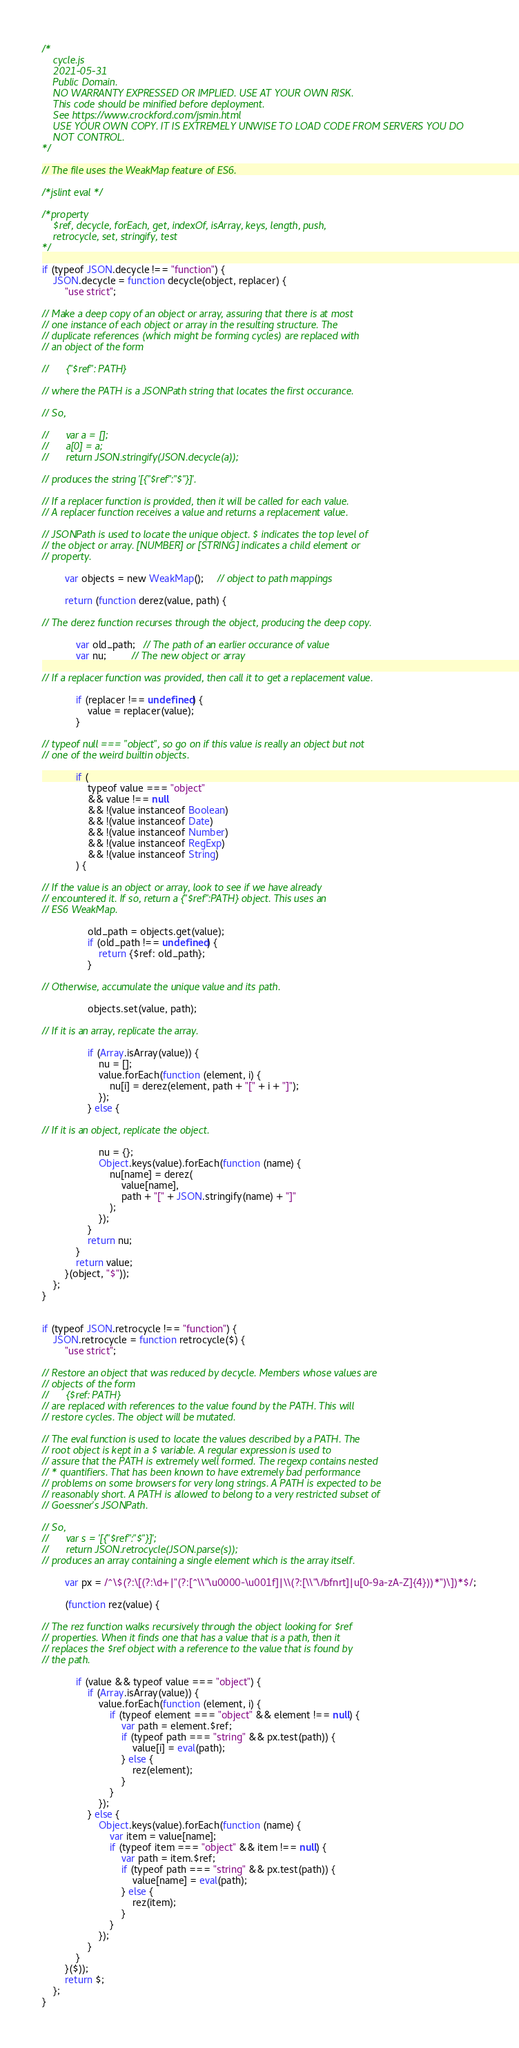<code> <loc_0><loc_0><loc_500><loc_500><_JavaScript_>/*
    cycle.js
    2021-05-31
    Public Domain.
    NO WARRANTY EXPRESSED OR IMPLIED. USE AT YOUR OWN RISK.
    This code should be minified before deployment.
    See https://www.crockford.com/jsmin.html
    USE YOUR OWN COPY. IT IS EXTREMELY UNWISE TO LOAD CODE FROM SERVERS YOU DO
    NOT CONTROL.
*/

// The file uses the WeakMap feature of ES6.

/*jslint eval */

/*property
    $ref, decycle, forEach, get, indexOf, isArray, keys, length, push,
    retrocycle, set, stringify, test
*/

if (typeof JSON.decycle !== "function") {
    JSON.decycle = function decycle(object, replacer) {
        "use strict";

// Make a deep copy of an object or array, assuring that there is at most
// one instance of each object or array in the resulting structure. The
// duplicate references (which might be forming cycles) are replaced with
// an object of the form

//      {"$ref": PATH}

// where the PATH is a JSONPath string that locates the first occurance.

// So,

//      var a = [];
//      a[0] = a;
//      return JSON.stringify(JSON.decycle(a));

// produces the string '[{"$ref":"$"}]'.

// If a replacer function is provided, then it will be called for each value.
// A replacer function receives a value and returns a replacement value.

// JSONPath is used to locate the unique object. $ indicates the top level of
// the object or array. [NUMBER] or [STRING] indicates a child element or
// property.

        var objects = new WeakMap();     // object to path mappings

        return (function derez(value, path) {

// The derez function recurses through the object, producing the deep copy.

            var old_path;   // The path of an earlier occurance of value
            var nu;         // The new object or array

// If a replacer function was provided, then call it to get a replacement value.

            if (replacer !== undefined) {
                value = replacer(value);
            }

// typeof null === "object", so go on if this value is really an object but not
// one of the weird builtin objects.

            if (
                typeof value === "object"
                && value !== null
                && !(value instanceof Boolean)
                && !(value instanceof Date)
                && !(value instanceof Number)
                && !(value instanceof RegExp)
                && !(value instanceof String)
            ) {

// If the value is an object or array, look to see if we have already
// encountered it. If so, return a {"$ref":PATH} object. This uses an
// ES6 WeakMap.

                old_path = objects.get(value);
                if (old_path !== undefined) {
                    return {$ref: old_path};
                }

// Otherwise, accumulate the unique value and its path.

                objects.set(value, path);

// If it is an array, replicate the array.

                if (Array.isArray(value)) {
                    nu = [];
                    value.forEach(function (element, i) {
                        nu[i] = derez(element, path + "[" + i + "]");
                    });
                } else {

// If it is an object, replicate the object.

                    nu = {};
                    Object.keys(value).forEach(function (name) {
                        nu[name] = derez(
                            value[name],
                            path + "[" + JSON.stringify(name) + "]"
                        );
                    });
                }
                return nu;
            }
            return value;
        }(object, "$"));
    };
}


if (typeof JSON.retrocycle !== "function") {
    JSON.retrocycle = function retrocycle($) {
        "use strict";

// Restore an object that was reduced by decycle. Members whose values are
// objects of the form
//      {$ref: PATH}
// are replaced with references to the value found by the PATH. This will
// restore cycles. The object will be mutated.

// The eval function is used to locate the values described by a PATH. The
// root object is kept in a $ variable. A regular expression is used to
// assure that the PATH is extremely well formed. The regexp contains nested
// * quantifiers. That has been known to have extremely bad performance
// problems on some browsers for very long strings. A PATH is expected to be
// reasonably short. A PATH is allowed to belong to a very restricted subset of
// Goessner's JSONPath.

// So,
//      var s = '[{"$ref":"$"}]';
//      return JSON.retrocycle(JSON.parse(s));
// produces an array containing a single element which is the array itself.

        var px = /^\$(?:\[(?:\d+|"(?:[^\\"\u0000-\u001f]|\\(?:[\\"\/bfnrt]|u[0-9a-zA-Z]{4}))*")\])*$/;

        (function rez(value) {

// The rez function walks recursively through the object looking for $ref
// properties. When it finds one that has a value that is a path, then it
// replaces the $ref object with a reference to the value that is found by
// the path.

            if (value && typeof value === "object") {
                if (Array.isArray(value)) {
                    value.forEach(function (element, i) {
                        if (typeof element === "object" && element !== null) {
                            var path = element.$ref;
                            if (typeof path === "string" && px.test(path)) {
                                value[i] = eval(path);
                            } else {
                                rez(element);
                            }
                        }
                    });
                } else {
                    Object.keys(value).forEach(function (name) {
                        var item = value[name];
                        if (typeof item === "object" && item !== null) {
                            var path = item.$ref;
                            if (typeof path === "string" && px.test(path)) {
                                value[name] = eval(path);
                            } else {
                                rez(item);
                            }
                        }
                    });
                }
            }
        }($));
        return $;
    };
}</code> 